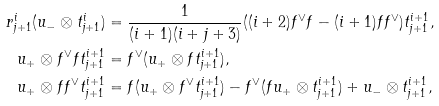<formula> <loc_0><loc_0><loc_500><loc_500>r ^ { i } _ { j + 1 } ( u _ { - } \otimes t ^ { i } _ { j + 1 } ) & = \frac { 1 } { ( i + 1 ) ( i + j + 3 ) } ( ( i + 2 ) f ^ { \vee } f - ( i + 1 ) f f ^ { \vee } ) t ^ { i + 1 } _ { j + 1 } , \\ u _ { + } \otimes f ^ { \vee } f t ^ { i + 1 } _ { j + 1 } & = f ^ { \vee } ( u _ { + } \otimes f t ^ { i + 1 } _ { j + 1 } ) , \\ u _ { + } \otimes f f ^ { \vee } t ^ { i + 1 } _ { j + 1 } & = f ( u _ { + } \otimes f ^ { \vee } t ^ { i + 1 } _ { j + 1 } ) - f ^ { \vee } ( f u _ { + } \otimes t ^ { i + 1 } _ { j + 1 } ) + u _ { - } \otimes t ^ { i + 1 } _ { j + 1 } ,</formula> 